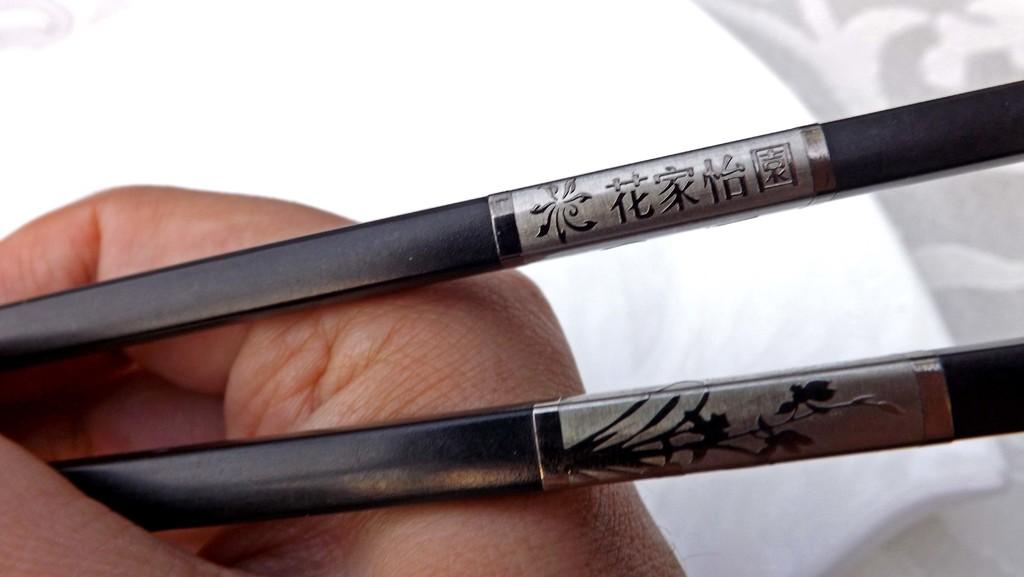What is the person holding in the image? There is a hand holding two sticks in the image. Can you describe the sticks? The sticks have a design on them. What is the color of the background in the image? The background of the image is white. How does the spy use the sticks in the image during the rainstorm? There is no spy or rainstorm present in the image; it only shows a hand holding two sticks with a design on them against a white background. 